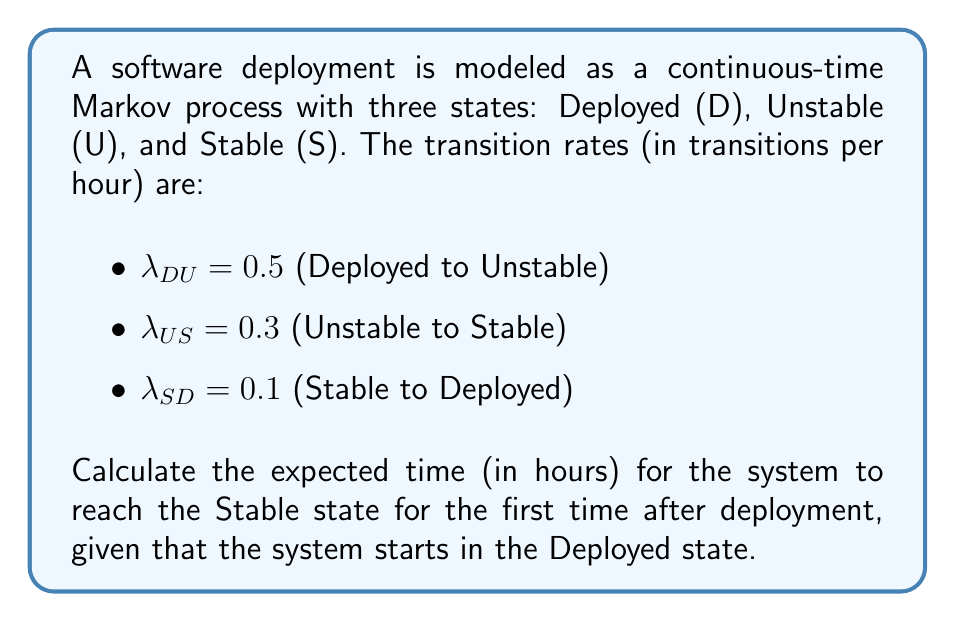Give your solution to this math problem. To solve this problem, we'll use the concept of mean first passage time in continuous-time Markov processes.

Step 1: Define the states
Let $m_D$ and $m_U$ be the mean first passage times to the Stable state from the Deployed and Unstable states, respectively.

Step 2: Set up the system of equations
For the Deployed state:
$$m_D = \frac{1}{\lambda_{DU}} + m_U$$

For the Unstable state:
$$m_U = \frac{1}{\lambda_{US}}$$

Step 3: Solve for $m_U$
$$m_U = \frac{1}{\lambda_{US}} = \frac{1}{0.3} = 3.33333$$

Step 4: Substitute $m_U$ into the equation for $m_D$
$$m_D = \frac{1}{\lambda_{DU}} + m_U$$
$$m_D = \frac{1}{0.5} + 3.33333$$
$$m_D = 2 + 3.33333 = 5.33333$$

Therefore, the expected time for the system to reach the Stable state for the first time after deployment is 5.33333 hours.
Answer: 5.33333 hours 